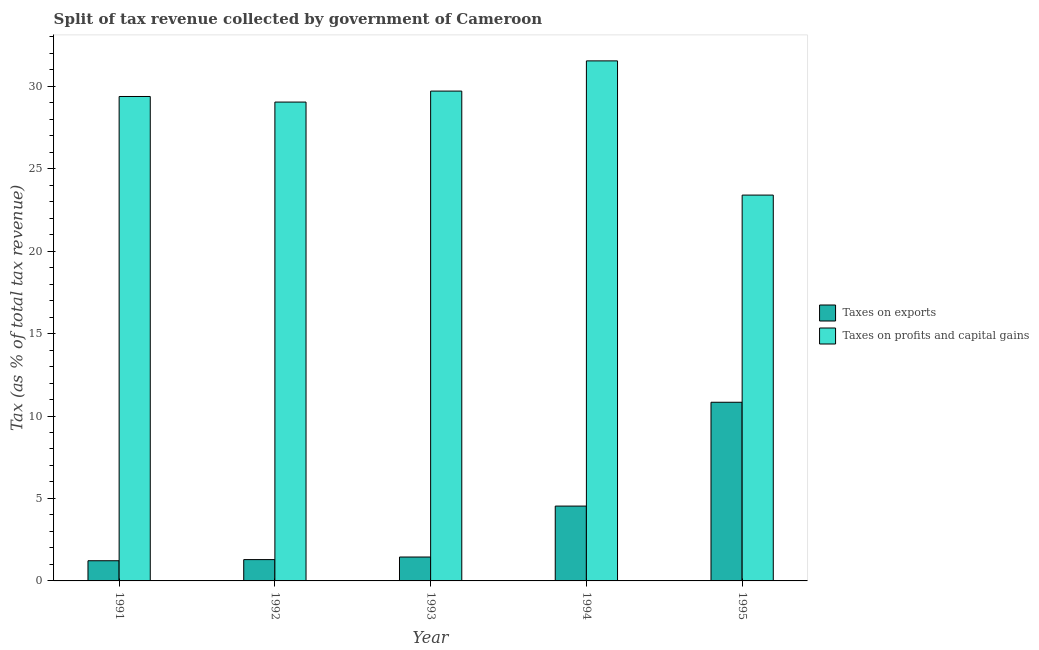How many bars are there on the 2nd tick from the left?
Make the answer very short. 2. In how many cases, is the number of bars for a given year not equal to the number of legend labels?
Provide a succinct answer. 0. What is the percentage of revenue obtained from taxes on profits and capital gains in 1993?
Make the answer very short. 29.7. Across all years, what is the maximum percentage of revenue obtained from taxes on profits and capital gains?
Your answer should be very brief. 31.54. Across all years, what is the minimum percentage of revenue obtained from taxes on profits and capital gains?
Provide a short and direct response. 23.4. In which year was the percentage of revenue obtained from taxes on profits and capital gains maximum?
Make the answer very short. 1994. What is the total percentage of revenue obtained from taxes on exports in the graph?
Your response must be concise. 19.34. What is the difference between the percentage of revenue obtained from taxes on profits and capital gains in 1992 and that in 1994?
Offer a very short reply. -2.5. What is the difference between the percentage of revenue obtained from taxes on profits and capital gains in 1995 and the percentage of revenue obtained from taxes on exports in 1992?
Your response must be concise. -5.64. What is the average percentage of revenue obtained from taxes on profits and capital gains per year?
Provide a succinct answer. 28.61. In the year 1994, what is the difference between the percentage of revenue obtained from taxes on exports and percentage of revenue obtained from taxes on profits and capital gains?
Provide a succinct answer. 0. What is the ratio of the percentage of revenue obtained from taxes on profits and capital gains in 1994 to that in 1995?
Your answer should be very brief. 1.35. Is the percentage of revenue obtained from taxes on exports in 1993 less than that in 1995?
Keep it short and to the point. Yes. Is the difference between the percentage of revenue obtained from taxes on profits and capital gains in 1991 and 1995 greater than the difference between the percentage of revenue obtained from taxes on exports in 1991 and 1995?
Provide a short and direct response. No. What is the difference between the highest and the second highest percentage of revenue obtained from taxes on profits and capital gains?
Offer a very short reply. 1.83. What is the difference between the highest and the lowest percentage of revenue obtained from taxes on exports?
Offer a terse response. 9.61. In how many years, is the percentage of revenue obtained from taxes on profits and capital gains greater than the average percentage of revenue obtained from taxes on profits and capital gains taken over all years?
Offer a terse response. 4. What does the 1st bar from the left in 1994 represents?
Offer a terse response. Taxes on exports. What does the 2nd bar from the right in 1994 represents?
Ensure brevity in your answer.  Taxes on exports. How many bars are there?
Give a very brief answer. 10. How many years are there in the graph?
Offer a very short reply. 5. Are the values on the major ticks of Y-axis written in scientific E-notation?
Provide a succinct answer. No. How are the legend labels stacked?
Offer a very short reply. Vertical. What is the title of the graph?
Provide a succinct answer. Split of tax revenue collected by government of Cameroon. Does "Taxes on profits and capital gains" appear as one of the legend labels in the graph?
Offer a terse response. Yes. What is the label or title of the X-axis?
Offer a very short reply. Year. What is the label or title of the Y-axis?
Keep it short and to the point. Tax (as % of total tax revenue). What is the Tax (as % of total tax revenue) of Taxes on exports in 1991?
Make the answer very short. 1.22. What is the Tax (as % of total tax revenue) of Taxes on profits and capital gains in 1991?
Offer a very short reply. 29.38. What is the Tax (as % of total tax revenue) in Taxes on exports in 1992?
Offer a terse response. 1.29. What is the Tax (as % of total tax revenue) of Taxes on profits and capital gains in 1992?
Offer a very short reply. 29.04. What is the Tax (as % of total tax revenue) of Taxes on exports in 1993?
Give a very brief answer. 1.45. What is the Tax (as % of total tax revenue) in Taxes on profits and capital gains in 1993?
Offer a very short reply. 29.7. What is the Tax (as % of total tax revenue) in Taxes on exports in 1994?
Your answer should be very brief. 4.54. What is the Tax (as % of total tax revenue) of Taxes on profits and capital gains in 1994?
Your answer should be compact. 31.54. What is the Tax (as % of total tax revenue) of Taxes on exports in 1995?
Your answer should be compact. 10.83. What is the Tax (as % of total tax revenue) of Taxes on profits and capital gains in 1995?
Offer a very short reply. 23.4. Across all years, what is the maximum Tax (as % of total tax revenue) in Taxes on exports?
Your answer should be very brief. 10.83. Across all years, what is the maximum Tax (as % of total tax revenue) of Taxes on profits and capital gains?
Offer a terse response. 31.54. Across all years, what is the minimum Tax (as % of total tax revenue) of Taxes on exports?
Your answer should be compact. 1.22. Across all years, what is the minimum Tax (as % of total tax revenue) in Taxes on profits and capital gains?
Offer a terse response. 23.4. What is the total Tax (as % of total tax revenue) of Taxes on exports in the graph?
Offer a terse response. 19.34. What is the total Tax (as % of total tax revenue) of Taxes on profits and capital gains in the graph?
Your answer should be very brief. 143.05. What is the difference between the Tax (as % of total tax revenue) of Taxes on exports in 1991 and that in 1992?
Ensure brevity in your answer.  -0.07. What is the difference between the Tax (as % of total tax revenue) of Taxes on profits and capital gains in 1991 and that in 1992?
Ensure brevity in your answer.  0.34. What is the difference between the Tax (as % of total tax revenue) in Taxes on exports in 1991 and that in 1993?
Provide a short and direct response. -0.23. What is the difference between the Tax (as % of total tax revenue) in Taxes on profits and capital gains in 1991 and that in 1993?
Provide a short and direct response. -0.33. What is the difference between the Tax (as % of total tax revenue) in Taxes on exports in 1991 and that in 1994?
Make the answer very short. -3.31. What is the difference between the Tax (as % of total tax revenue) of Taxes on profits and capital gains in 1991 and that in 1994?
Your answer should be very brief. -2.16. What is the difference between the Tax (as % of total tax revenue) of Taxes on exports in 1991 and that in 1995?
Give a very brief answer. -9.61. What is the difference between the Tax (as % of total tax revenue) of Taxes on profits and capital gains in 1991 and that in 1995?
Make the answer very short. 5.98. What is the difference between the Tax (as % of total tax revenue) of Taxes on exports in 1992 and that in 1993?
Offer a terse response. -0.16. What is the difference between the Tax (as % of total tax revenue) of Taxes on profits and capital gains in 1992 and that in 1993?
Make the answer very short. -0.67. What is the difference between the Tax (as % of total tax revenue) of Taxes on exports in 1992 and that in 1994?
Give a very brief answer. -3.24. What is the difference between the Tax (as % of total tax revenue) of Taxes on profits and capital gains in 1992 and that in 1994?
Keep it short and to the point. -2.5. What is the difference between the Tax (as % of total tax revenue) in Taxes on exports in 1992 and that in 1995?
Make the answer very short. -9.54. What is the difference between the Tax (as % of total tax revenue) of Taxes on profits and capital gains in 1992 and that in 1995?
Ensure brevity in your answer.  5.64. What is the difference between the Tax (as % of total tax revenue) in Taxes on exports in 1993 and that in 1994?
Provide a succinct answer. -3.09. What is the difference between the Tax (as % of total tax revenue) of Taxes on profits and capital gains in 1993 and that in 1994?
Provide a short and direct response. -1.83. What is the difference between the Tax (as % of total tax revenue) of Taxes on exports in 1993 and that in 1995?
Your response must be concise. -9.39. What is the difference between the Tax (as % of total tax revenue) of Taxes on profits and capital gains in 1993 and that in 1995?
Ensure brevity in your answer.  6.31. What is the difference between the Tax (as % of total tax revenue) of Taxes on exports in 1994 and that in 1995?
Offer a very short reply. -6.3. What is the difference between the Tax (as % of total tax revenue) of Taxes on profits and capital gains in 1994 and that in 1995?
Ensure brevity in your answer.  8.14. What is the difference between the Tax (as % of total tax revenue) of Taxes on exports in 1991 and the Tax (as % of total tax revenue) of Taxes on profits and capital gains in 1992?
Make the answer very short. -27.81. What is the difference between the Tax (as % of total tax revenue) in Taxes on exports in 1991 and the Tax (as % of total tax revenue) in Taxes on profits and capital gains in 1993?
Make the answer very short. -28.48. What is the difference between the Tax (as % of total tax revenue) in Taxes on exports in 1991 and the Tax (as % of total tax revenue) in Taxes on profits and capital gains in 1994?
Offer a terse response. -30.31. What is the difference between the Tax (as % of total tax revenue) of Taxes on exports in 1991 and the Tax (as % of total tax revenue) of Taxes on profits and capital gains in 1995?
Keep it short and to the point. -22.17. What is the difference between the Tax (as % of total tax revenue) of Taxes on exports in 1992 and the Tax (as % of total tax revenue) of Taxes on profits and capital gains in 1993?
Give a very brief answer. -28.41. What is the difference between the Tax (as % of total tax revenue) of Taxes on exports in 1992 and the Tax (as % of total tax revenue) of Taxes on profits and capital gains in 1994?
Offer a very short reply. -30.24. What is the difference between the Tax (as % of total tax revenue) of Taxes on exports in 1992 and the Tax (as % of total tax revenue) of Taxes on profits and capital gains in 1995?
Offer a terse response. -22.1. What is the difference between the Tax (as % of total tax revenue) in Taxes on exports in 1993 and the Tax (as % of total tax revenue) in Taxes on profits and capital gains in 1994?
Ensure brevity in your answer.  -30.09. What is the difference between the Tax (as % of total tax revenue) in Taxes on exports in 1993 and the Tax (as % of total tax revenue) in Taxes on profits and capital gains in 1995?
Provide a succinct answer. -21.95. What is the difference between the Tax (as % of total tax revenue) of Taxes on exports in 1994 and the Tax (as % of total tax revenue) of Taxes on profits and capital gains in 1995?
Ensure brevity in your answer.  -18.86. What is the average Tax (as % of total tax revenue) in Taxes on exports per year?
Your answer should be very brief. 3.87. What is the average Tax (as % of total tax revenue) in Taxes on profits and capital gains per year?
Offer a terse response. 28.61. In the year 1991, what is the difference between the Tax (as % of total tax revenue) in Taxes on exports and Tax (as % of total tax revenue) in Taxes on profits and capital gains?
Your answer should be very brief. -28.15. In the year 1992, what is the difference between the Tax (as % of total tax revenue) in Taxes on exports and Tax (as % of total tax revenue) in Taxes on profits and capital gains?
Your answer should be compact. -27.75. In the year 1993, what is the difference between the Tax (as % of total tax revenue) of Taxes on exports and Tax (as % of total tax revenue) of Taxes on profits and capital gains?
Your answer should be very brief. -28.25. In the year 1994, what is the difference between the Tax (as % of total tax revenue) in Taxes on exports and Tax (as % of total tax revenue) in Taxes on profits and capital gains?
Your response must be concise. -27. In the year 1995, what is the difference between the Tax (as % of total tax revenue) in Taxes on exports and Tax (as % of total tax revenue) in Taxes on profits and capital gains?
Your response must be concise. -12.56. What is the ratio of the Tax (as % of total tax revenue) of Taxes on exports in 1991 to that in 1992?
Make the answer very short. 0.95. What is the ratio of the Tax (as % of total tax revenue) of Taxes on profits and capital gains in 1991 to that in 1992?
Your answer should be very brief. 1.01. What is the ratio of the Tax (as % of total tax revenue) in Taxes on exports in 1991 to that in 1993?
Ensure brevity in your answer.  0.84. What is the ratio of the Tax (as % of total tax revenue) in Taxes on profits and capital gains in 1991 to that in 1993?
Provide a short and direct response. 0.99. What is the ratio of the Tax (as % of total tax revenue) in Taxes on exports in 1991 to that in 1994?
Offer a very short reply. 0.27. What is the ratio of the Tax (as % of total tax revenue) of Taxes on profits and capital gains in 1991 to that in 1994?
Make the answer very short. 0.93. What is the ratio of the Tax (as % of total tax revenue) of Taxes on exports in 1991 to that in 1995?
Ensure brevity in your answer.  0.11. What is the ratio of the Tax (as % of total tax revenue) in Taxes on profits and capital gains in 1991 to that in 1995?
Offer a very short reply. 1.26. What is the ratio of the Tax (as % of total tax revenue) of Taxes on exports in 1992 to that in 1993?
Your answer should be compact. 0.89. What is the ratio of the Tax (as % of total tax revenue) in Taxes on profits and capital gains in 1992 to that in 1993?
Make the answer very short. 0.98. What is the ratio of the Tax (as % of total tax revenue) in Taxes on exports in 1992 to that in 1994?
Your answer should be very brief. 0.28. What is the ratio of the Tax (as % of total tax revenue) in Taxes on profits and capital gains in 1992 to that in 1994?
Your answer should be compact. 0.92. What is the ratio of the Tax (as % of total tax revenue) of Taxes on exports in 1992 to that in 1995?
Offer a terse response. 0.12. What is the ratio of the Tax (as % of total tax revenue) in Taxes on profits and capital gains in 1992 to that in 1995?
Keep it short and to the point. 1.24. What is the ratio of the Tax (as % of total tax revenue) in Taxes on exports in 1993 to that in 1994?
Offer a terse response. 0.32. What is the ratio of the Tax (as % of total tax revenue) of Taxes on profits and capital gains in 1993 to that in 1994?
Make the answer very short. 0.94. What is the ratio of the Tax (as % of total tax revenue) of Taxes on exports in 1993 to that in 1995?
Offer a very short reply. 0.13. What is the ratio of the Tax (as % of total tax revenue) in Taxes on profits and capital gains in 1993 to that in 1995?
Provide a short and direct response. 1.27. What is the ratio of the Tax (as % of total tax revenue) in Taxes on exports in 1994 to that in 1995?
Your answer should be very brief. 0.42. What is the ratio of the Tax (as % of total tax revenue) of Taxes on profits and capital gains in 1994 to that in 1995?
Offer a terse response. 1.35. What is the difference between the highest and the second highest Tax (as % of total tax revenue) in Taxes on exports?
Keep it short and to the point. 6.3. What is the difference between the highest and the second highest Tax (as % of total tax revenue) of Taxes on profits and capital gains?
Make the answer very short. 1.83. What is the difference between the highest and the lowest Tax (as % of total tax revenue) in Taxes on exports?
Offer a very short reply. 9.61. What is the difference between the highest and the lowest Tax (as % of total tax revenue) in Taxes on profits and capital gains?
Give a very brief answer. 8.14. 